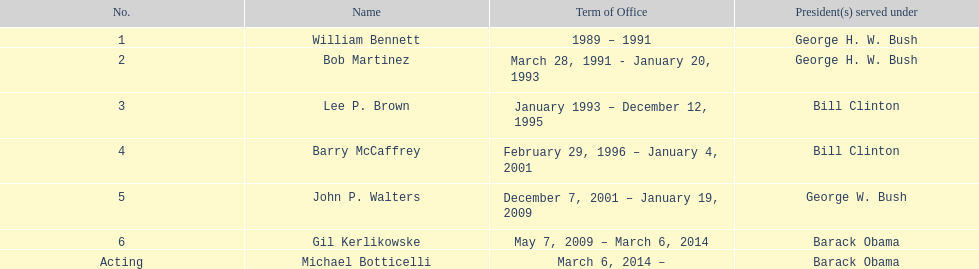How long did lee p. brown serve for? 2 years. 